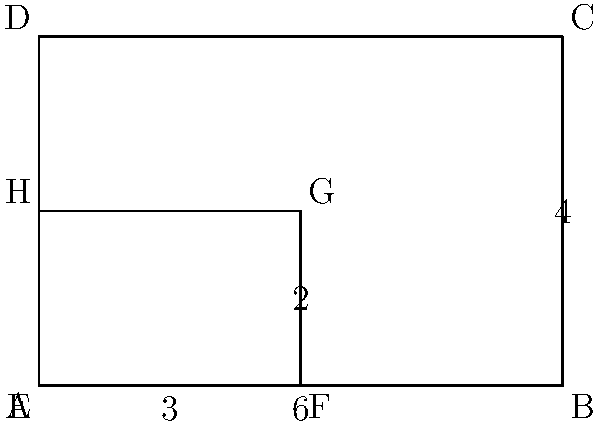In the diagram, rectangle ABCD is similar to rectangle EFGH. If the length of AB is 6 units and the length of EF is 3 units, what is the ratio of the perimeter of ABCD to the perimeter of EFGH? Let's approach this step-by-step:

1) First, we need to understand what similarity means. Similar shapes have the same proportions, which means their corresponding sides are in the same ratio.

2) We're given that AB = 6 and EF = 3. This tells us the ratio of corresponding sides:
   $\frac{AB}{EF} = \frac{6}{3} = 2$

3) This ratio applies to all corresponding sides. So if AB is twice EF, then BC must also be twice FG, and so on.

4) We can see that BC = 4 (given in the diagram). Therefore, FG must be half of this: FG = 2.

5) Now we can calculate the perimeters:
   Perimeter of ABCD = AB + BC + CD + DA = 6 + 4 + 6 + 4 = 20
   Perimeter of EFGH = EF + FG + GH + HE = 3 + 2 + 3 + 2 = 10

6) The ratio of the perimeters is:
   $\frac{Perimeter of ABCD}{Perimeter of EFGH} = \frac{20}{10} = 2$

7) Notice that this is the same as the ratio of corresponding sides we found in step 2. This is always true for similar shapes: the ratio of any linear measurement (side length, perimeter, diagonal, etc.) is constant.
Answer: 2:1 